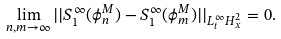<formula> <loc_0><loc_0><loc_500><loc_500>\lim _ { n , m \to \infty } | | S ^ { \infty } _ { 1 } ( \phi _ { n } ^ { M } ) - S ^ { \infty } _ { 1 } ( \phi _ { m } ^ { M } ) | | _ { L ^ { \infty } _ { t } H ^ { 2 } _ { x } } = 0 .</formula> 